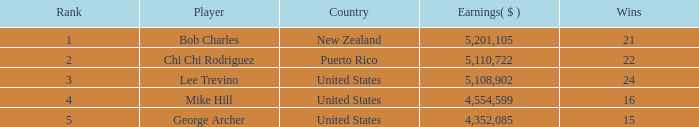What was the cumulative amount earned by george archer from the united states, considering he had fewer than 24 wins and a ranking greater than 5? 0.0. 